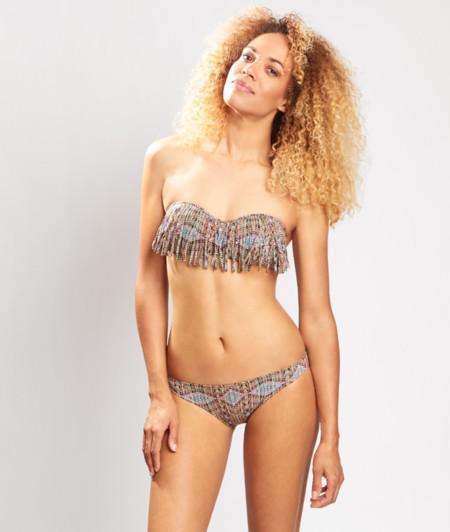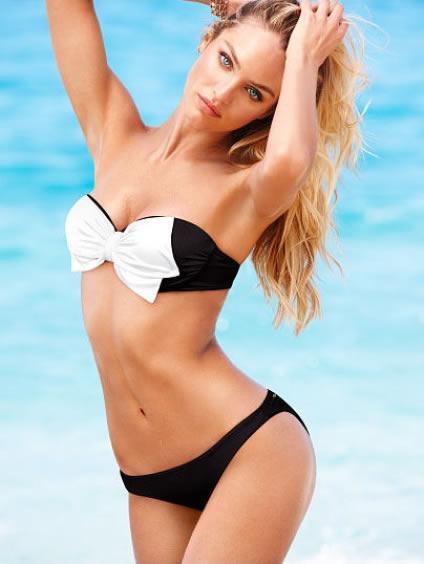The first image is the image on the left, the second image is the image on the right. Assess this claim about the two images: "A woman is touching her hair.". Correct or not? Answer yes or no. Yes. The first image is the image on the left, the second image is the image on the right. For the images displayed, is the sentence "One image shows a girl in a bikini with straps and solid color, standing with one hand on her upper hip." factually correct? Answer yes or no. No. 